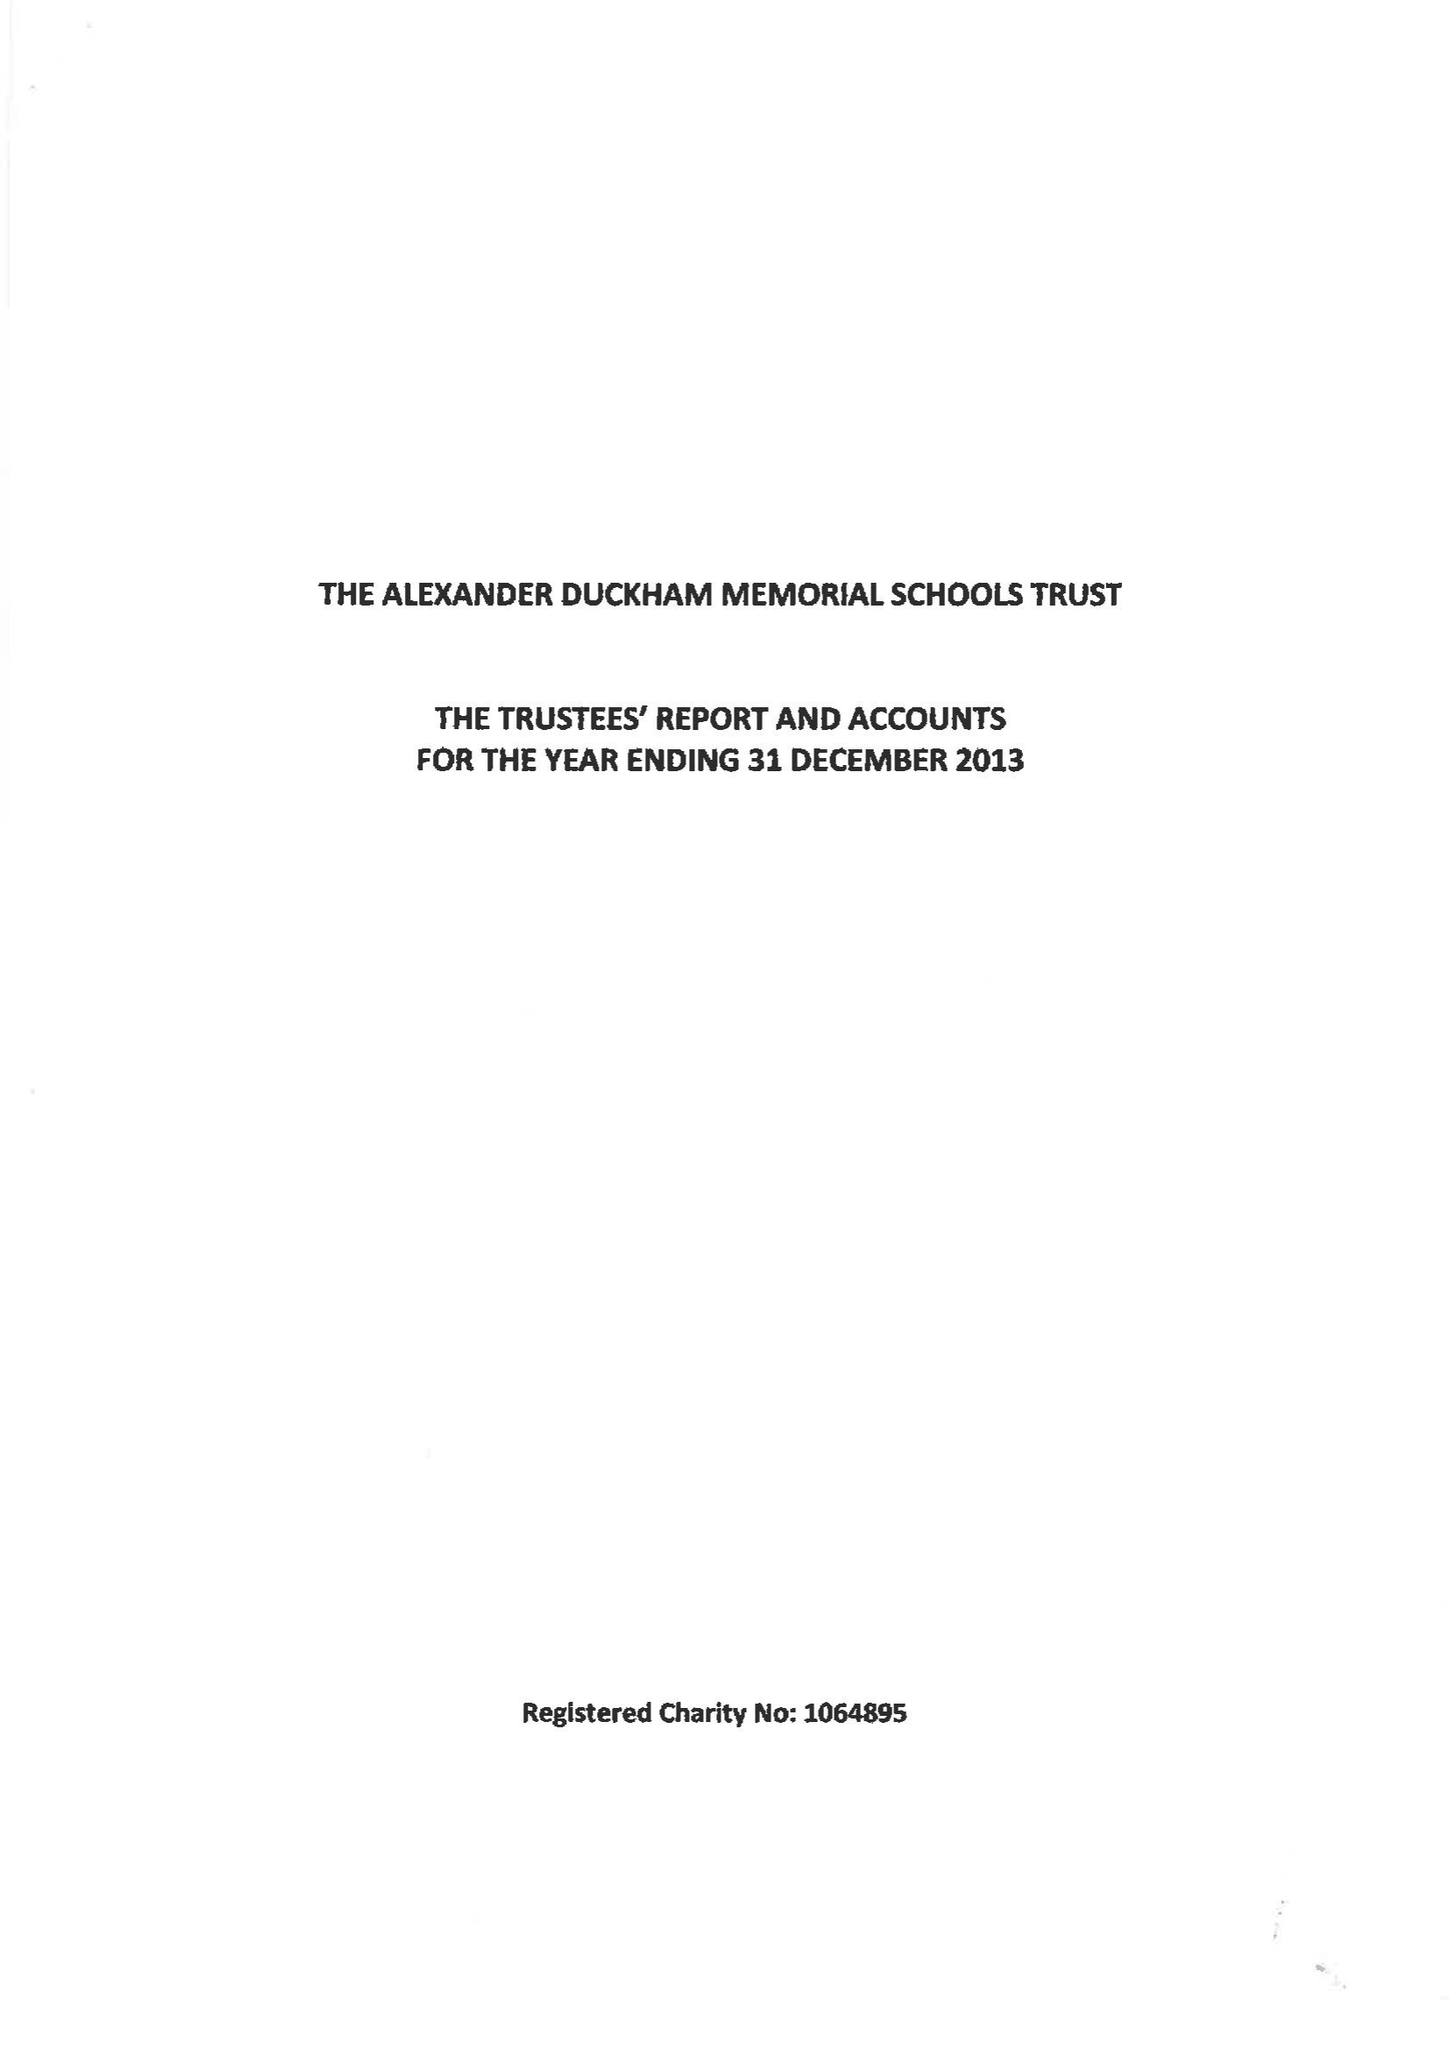What is the value for the spending_annually_in_british_pounds?
Answer the question using a single word or phrase. 87676.00 